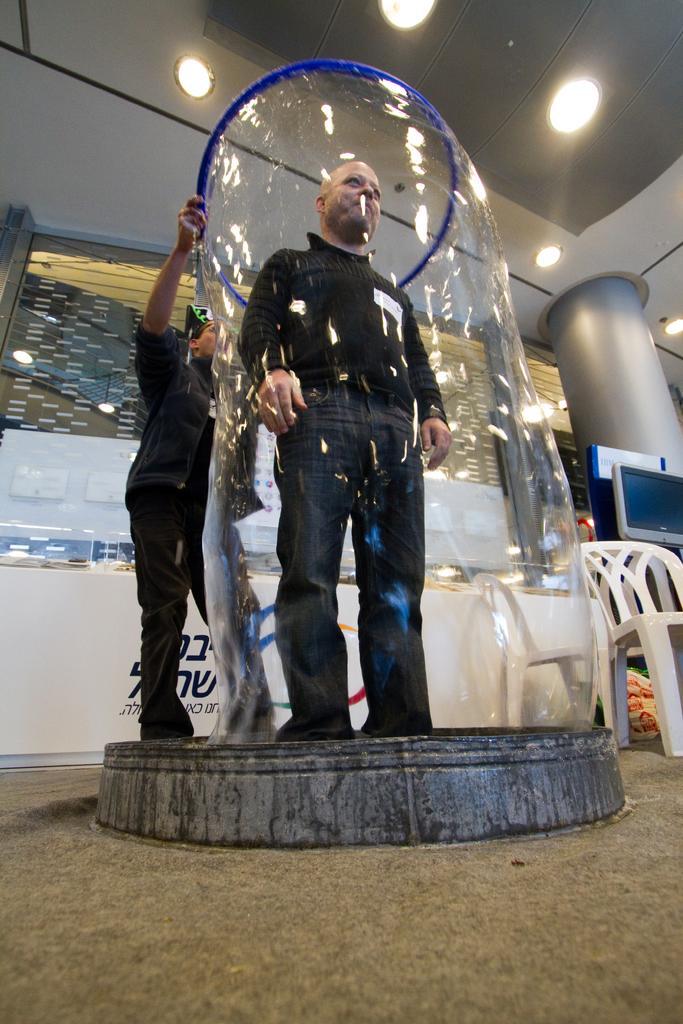Could you give a brief overview of what you see in this image? In the center of the image there is a person standing inside a soap bubble. Behind him there is another person. At the top of the image there are lights to the ceiling. At the right side of the image there is a chair. 